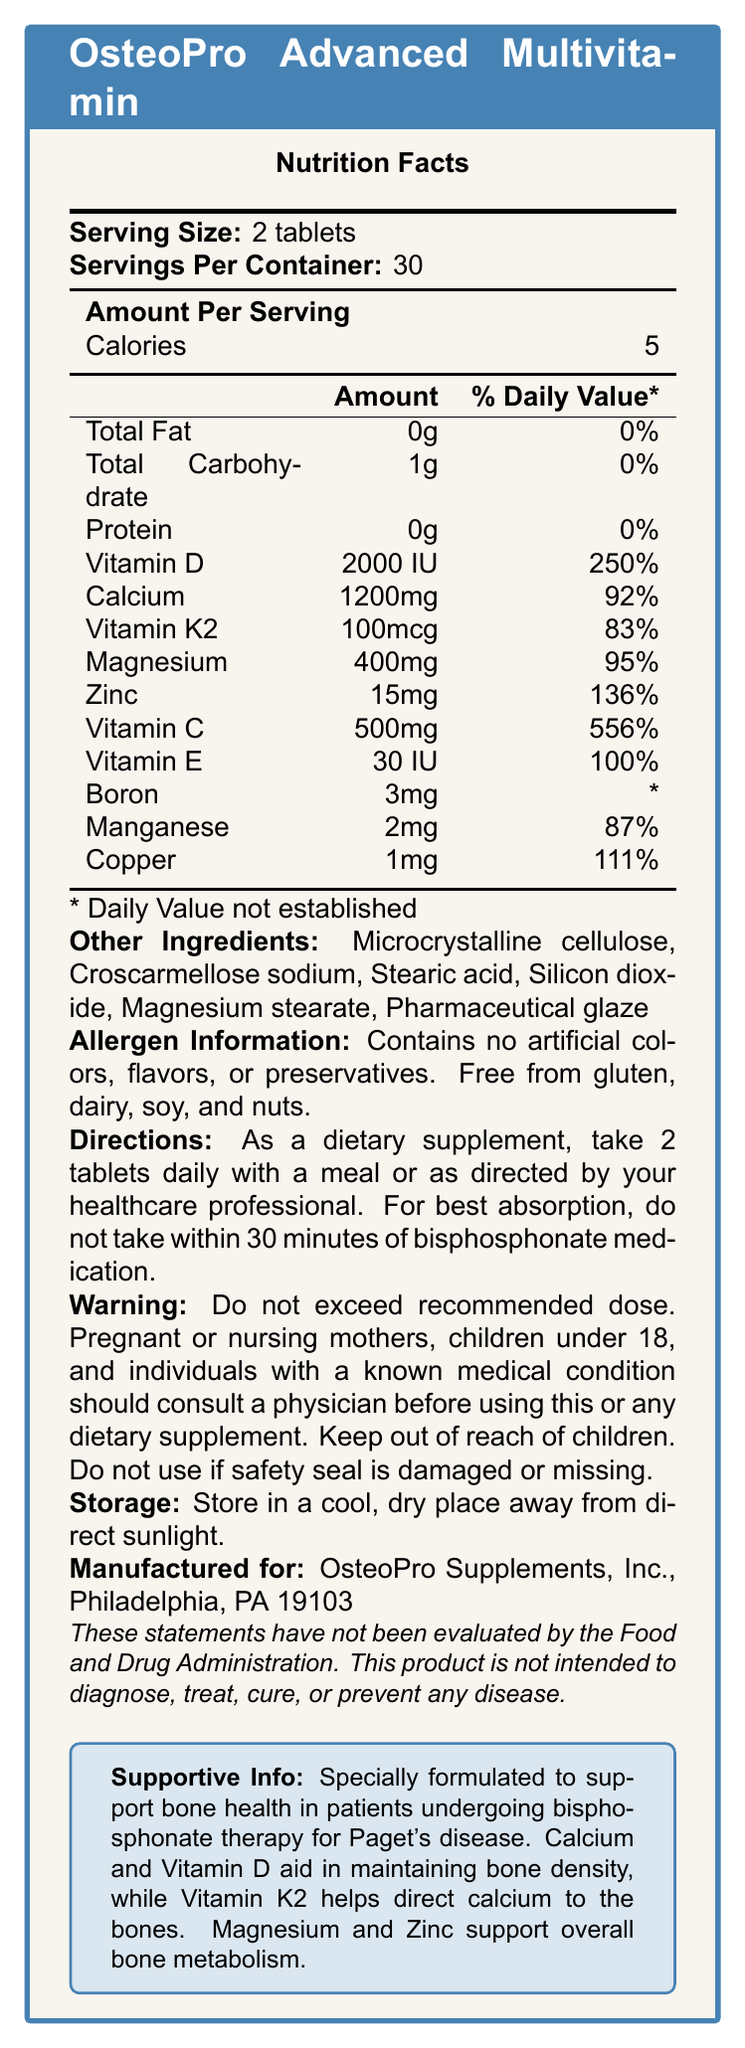what is the serving size? The document specifies that the serving size for OsteoPro Advanced Multivitamin is 2 tablets.
Answer: 2 tablets how many calories are in one serving? The document indicates that each serving of OsteoPro Advanced Multivitamin contains 5 calories.
Answer: 5 what percentage of daily value of vitamin D does one serving provide? The document states that one serving of OsteoPro Advanced Multivitamin provides 250% of the daily value of vitamin D.
Answer: 250% what is the amount of zinc per serving? The nutrition facts label lists the amount of zinc per serving as 15mg.
Answer: 15mg does the product contain any dairy ingredients? The allergen information section indicates that the product is free from gluten, dairy, soy, and nuts.
Answer: No who is the manufacturer of OsteoPro Advanced Multivitamin? The manufacturer information provided in the document lists OsteoPro Supplements, Inc., Philadelphia, PA 19103 as the manufacturer.
Answer: OsteoPro Supplements, Inc., Philadelphia, PA 19103 which ingredient helps with calcium absorption? A. Boron B. Vitamin K2 C. Vitamin C D. Manganese The supportive information indicates that Vitamin K2 helps direct calcium to the bones for better absorption.
Answer: B where should the product be stored? A. In the refrigerator B. In a cool, dry place away from direct sunlight C. Near a heat source D. In the freezer The document provides storage instructions that state the product should be stored in a cool, dry place away from direct sunlight.
Answer: B is it recommended to exceed the daily dose? The warning statement advises against exceeding the recommended dose.
Answer: No summarize the main purpose of the OsteoPro Advanced Multivitamin. The summary of the document covers the main purpose, key components, and important usage and storage information of the OsteoPro Advanced Multivitamin.
Answer: OsteoPro Advanced Multivitamin is a specialized multivitamin supplement formulated to support bone health in patients undergoing bisphosphonate therapy for Paget's disease. It contains key vitamins and minerals like Calcium, Vitamin D, Vitamin K2, Magnesium, and Zinc that are essential for maintaining bone density and overall bone metabolism. The document emphasizes the importance of proper usage and storage while highlighting its allergen-free formulation. what is the daily value percentage of vitamin C in one serving? According to the nutrition facts label, one serving of OsteoPro Advanced Multivitamin provides 556% of the daily value of Vitamin C.
Answer: 556% what are the other ingredients listed in the product? The document lists these items as "other ingredients" in the OsteoPro Advanced Multivitamin.
Answer: Microcrystalline cellulose, Croscarmellose sodium, Stearic acid, Silicon dioxide, Magnesium stearate, Pharmaceutical glaze can children under 18 take this supplement without consulting a physician? The warning statement advises that children under 18 should consult a physician before using this dietary supplement.
Answer: No what additional benefits does the supportive information claim the supplement provides for patients undergoing bisphosphonate therapy for Paget's disease? The supportive information describes that Calcium and Vitamin D aid in maintaining bone density, Vitamin K2 helps direct calcium to the bones, and Magnesium and Zinc support overall bone metabolism.
Answer: Supports bone density, directs calcium to the bones, and supports overall bone metabolism how many servings are there in one container? The document mentions that there are 30 servings per container.
Answer: 30 which ingredient's daily value percentage is not established? The nutrition label indicates that the daily value for Boron is not established.
Answer: Boron are there any artificial colors, flavors, or preservatives in the product? The allergen information section states that the product contains no artificial colors, flavors, or preservatives.
Answer: No what is the amount of copper per serving? The nutrition facts label lists the amount of copper per serving as 1mg.
Answer: 1mg how many total carbohydrates are in one serving? The document specifies that there is 1g of total carbohydrates per serving.
Answer: 1g what should you do if the safety seal is damaged or missing? The warning statement advises not to use the product if the safety seal is damaged or missing.
Answer: Do not use how many tablets should be taken daily? A. 1 tablet B. 2 tablets C. 3 tablets D. 4 tablets The directions specify that the recommended daily serving size is 2 tablets.
Answer: B 